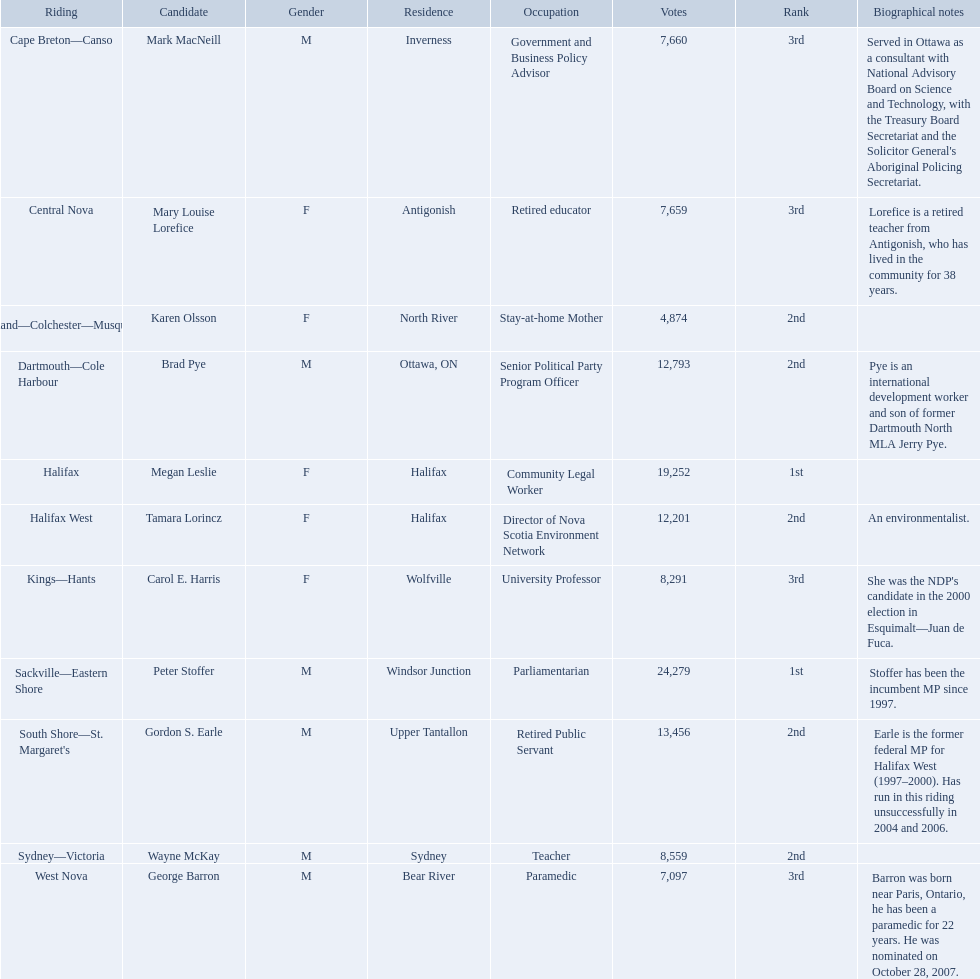Who are all the candidates? Mark MacNeill, Mary Louise Lorefice, Karen Olsson, Brad Pye, Megan Leslie, Tamara Lorincz, Carol E. Harris, Peter Stoffer, Gordon S. Earle, Wayne McKay, George Barron. How many votes did they receive? 7,660, 7,659, 4,874, 12,793, 19,252, 12,201, 8,291, 24,279, 13,456, 8,559, 7,097. And of those, how many were for megan leslie? 19,252. 